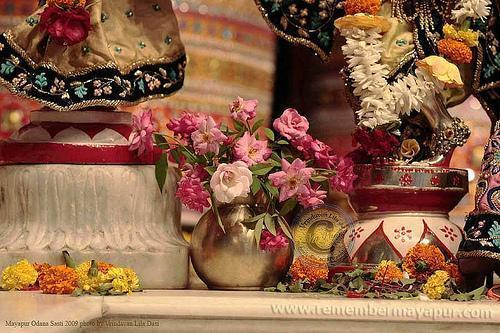How many vases are there?
Give a very brief answer. 2. 